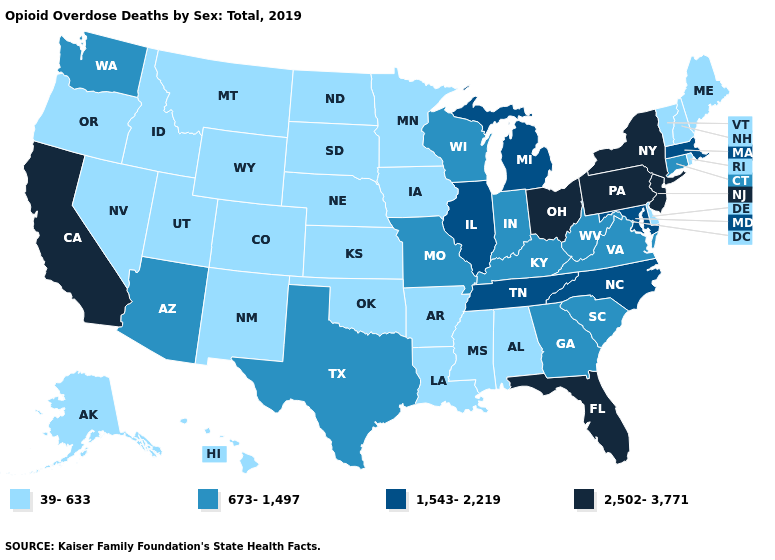Does the first symbol in the legend represent the smallest category?
Give a very brief answer. Yes. What is the highest value in the USA?
Quick response, please. 2,502-3,771. Which states have the lowest value in the USA?
Write a very short answer. Alabama, Alaska, Arkansas, Colorado, Delaware, Hawaii, Idaho, Iowa, Kansas, Louisiana, Maine, Minnesota, Mississippi, Montana, Nebraska, Nevada, New Hampshire, New Mexico, North Dakota, Oklahoma, Oregon, Rhode Island, South Dakota, Utah, Vermont, Wyoming. What is the lowest value in states that border Maine?
Short answer required. 39-633. Name the states that have a value in the range 673-1,497?
Quick response, please. Arizona, Connecticut, Georgia, Indiana, Kentucky, Missouri, South Carolina, Texas, Virginia, Washington, West Virginia, Wisconsin. Which states have the lowest value in the USA?
Short answer required. Alabama, Alaska, Arkansas, Colorado, Delaware, Hawaii, Idaho, Iowa, Kansas, Louisiana, Maine, Minnesota, Mississippi, Montana, Nebraska, Nevada, New Hampshire, New Mexico, North Dakota, Oklahoma, Oregon, Rhode Island, South Dakota, Utah, Vermont, Wyoming. What is the value of Arkansas?
Short answer required. 39-633. Does Maryland have the highest value in the USA?
Write a very short answer. No. What is the highest value in states that border Georgia?
Keep it brief. 2,502-3,771. How many symbols are there in the legend?
Be succinct. 4. Which states have the highest value in the USA?
Write a very short answer. California, Florida, New Jersey, New York, Ohio, Pennsylvania. Name the states that have a value in the range 39-633?
Concise answer only. Alabama, Alaska, Arkansas, Colorado, Delaware, Hawaii, Idaho, Iowa, Kansas, Louisiana, Maine, Minnesota, Mississippi, Montana, Nebraska, Nevada, New Hampshire, New Mexico, North Dakota, Oklahoma, Oregon, Rhode Island, South Dakota, Utah, Vermont, Wyoming. What is the lowest value in the USA?
Short answer required. 39-633. What is the value of Kansas?
Keep it brief. 39-633. Among the states that border Indiana , which have the highest value?
Be succinct. Ohio. 